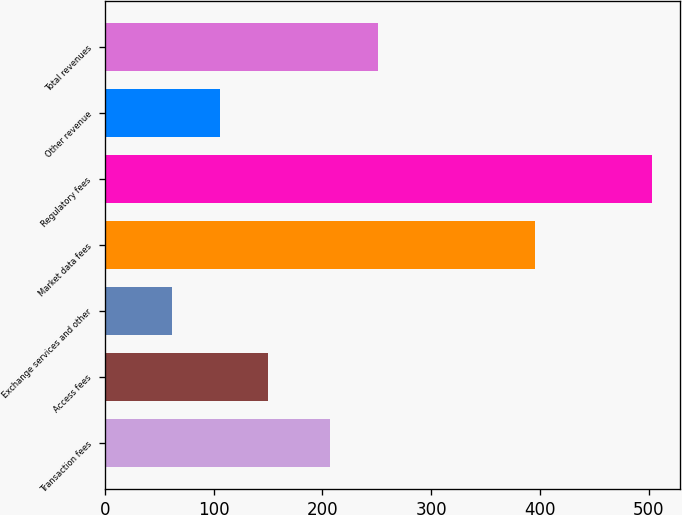Convert chart. <chart><loc_0><loc_0><loc_500><loc_500><bar_chart><fcel>Transaction fees<fcel>Access fees<fcel>Exchange services and other<fcel>Market data fees<fcel>Regulatory fees<fcel>Other revenue<fcel>Total revenues<nl><fcel>207.3<fcel>149.98<fcel>61.6<fcel>395.5<fcel>503.5<fcel>105.79<fcel>251.49<nl></chart> 